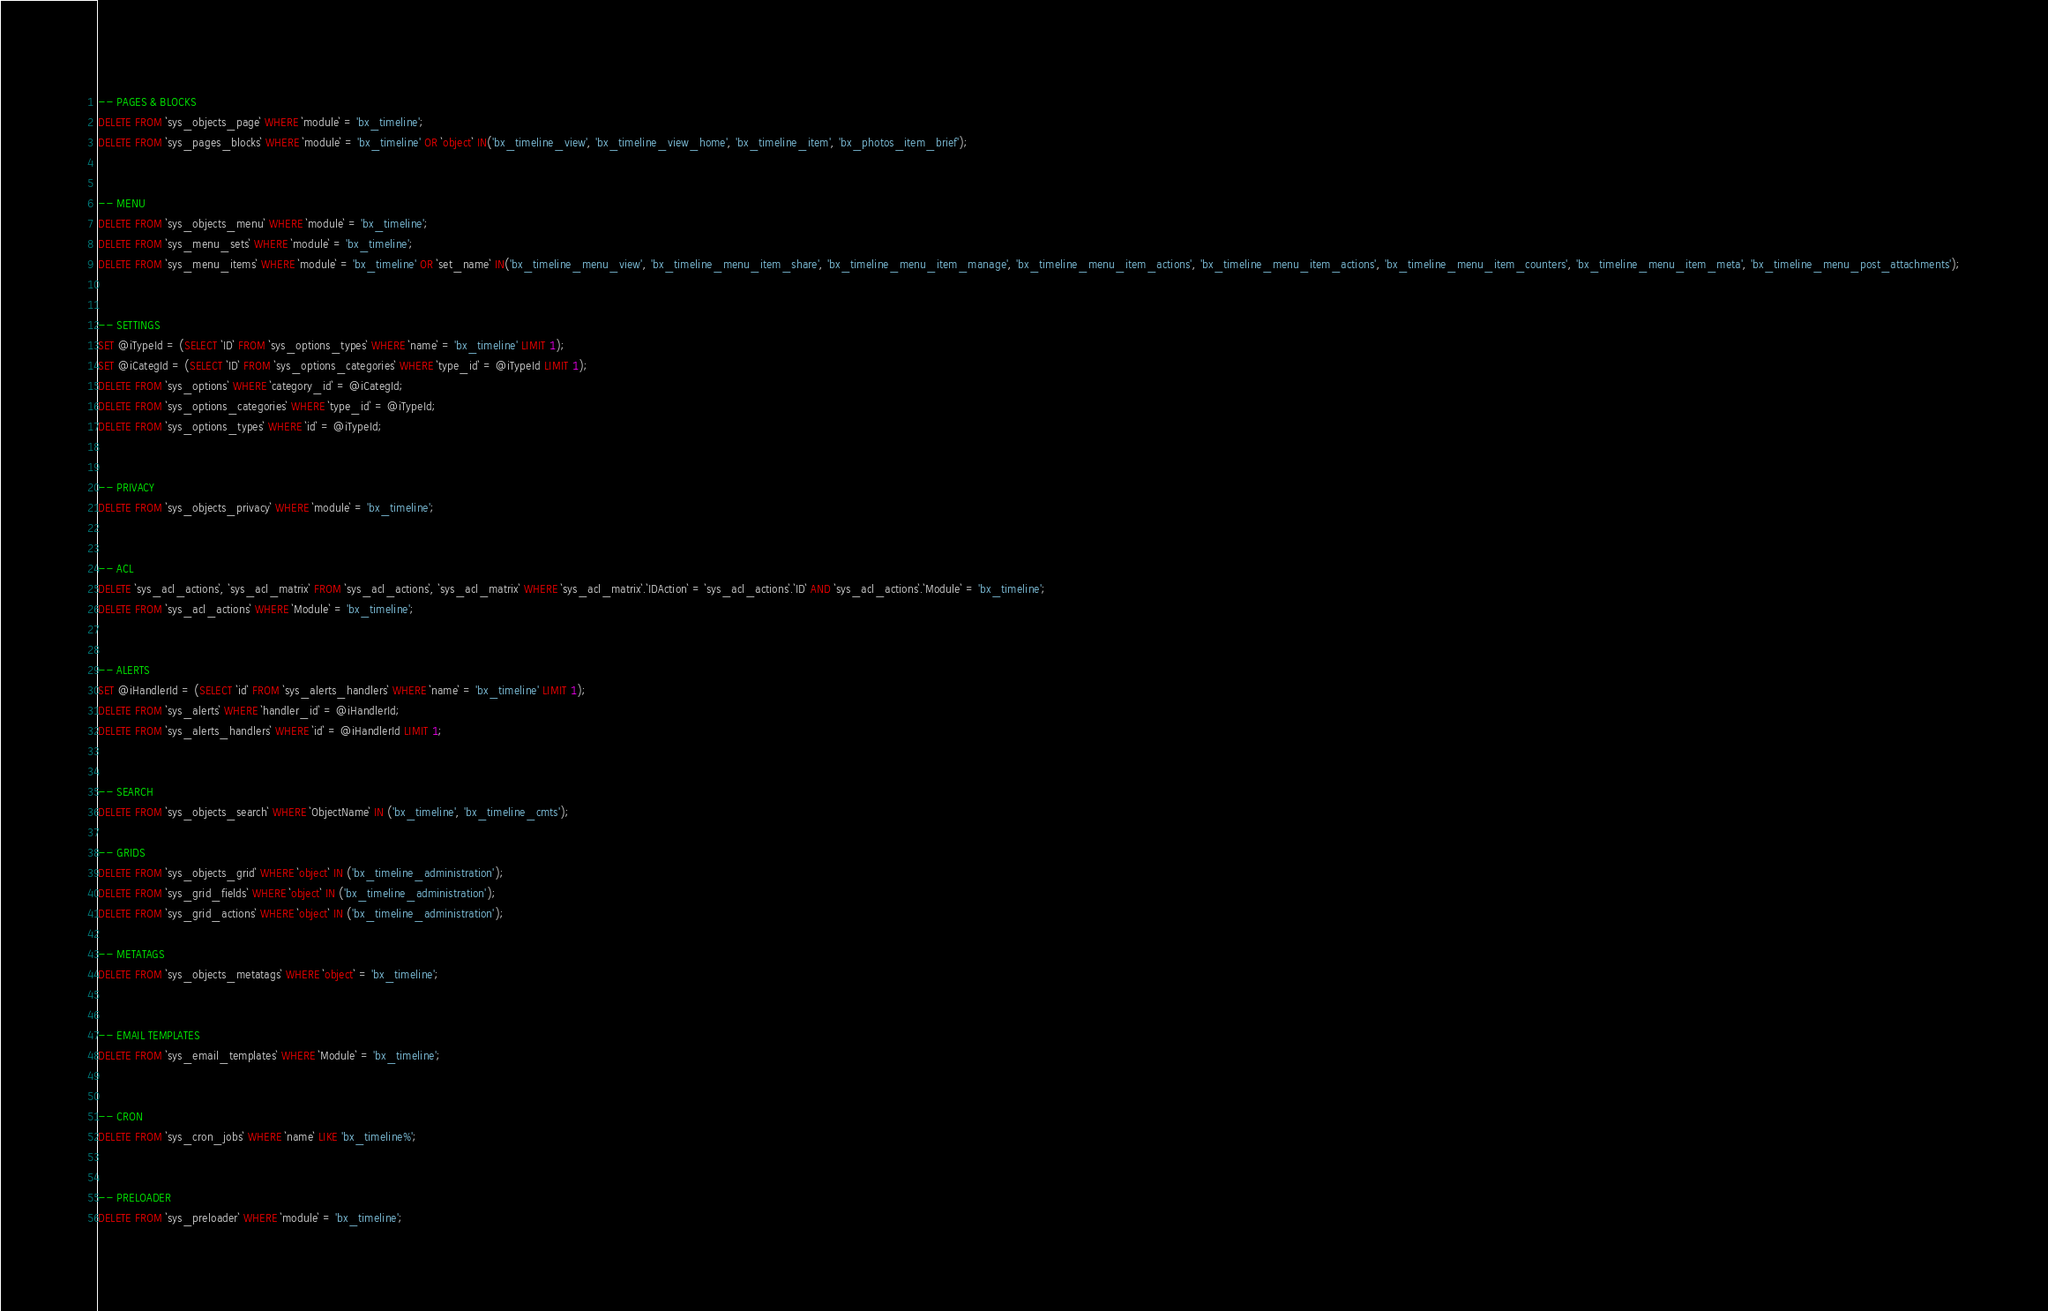Convert code to text. <code><loc_0><loc_0><loc_500><loc_500><_SQL_>-- PAGES & BLOCKS
DELETE FROM `sys_objects_page` WHERE `module` = 'bx_timeline';
DELETE FROM `sys_pages_blocks` WHERE `module` = 'bx_timeline' OR `object` IN('bx_timeline_view', 'bx_timeline_view_home', 'bx_timeline_item', 'bx_photos_item_brief');


-- MENU
DELETE FROM `sys_objects_menu` WHERE `module` = 'bx_timeline';
DELETE FROM `sys_menu_sets` WHERE `module` = 'bx_timeline';
DELETE FROM `sys_menu_items` WHERE `module` = 'bx_timeline' OR `set_name` IN('bx_timeline_menu_view', 'bx_timeline_menu_item_share', 'bx_timeline_menu_item_manage', 'bx_timeline_menu_item_actions', 'bx_timeline_menu_item_actions', 'bx_timeline_menu_item_counters', 'bx_timeline_menu_item_meta', 'bx_timeline_menu_post_attachments');


-- SETTINGS
SET @iTypeId = (SELECT `ID` FROM `sys_options_types` WHERE `name` = 'bx_timeline' LIMIT 1);
SET @iCategId = (SELECT `ID` FROM `sys_options_categories` WHERE `type_id` = @iTypeId LIMIT 1);
DELETE FROM `sys_options` WHERE `category_id` = @iCategId;
DELETE FROM `sys_options_categories` WHERE `type_id` = @iTypeId;
DELETE FROM `sys_options_types` WHERE `id` = @iTypeId;


-- PRIVACY 
DELETE FROM `sys_objects_privacy` WHERE `module` = 'bx_timeline';


-- ACL
DELETE `sys_acl_actions`, `sys_acl_matrix` FROM `sys_acl_actions`, `sys_acl_matrix` WHERE `sys_acl_matrix`.`IDAction` = `sys_acl_actions`.`ID` AND `sys_acl_actions`.`Module` = 'bx_timeline';
DELETE FROM `sys_acl_actions` WHERE `Module` = 'bx_timeline';


-- ALERTS
SET @iHandlerId = (SELECT `id` FROM `sys_alerts_handlers` WHERE `name` = 'bx_timeline' LIMIT 1);
DELETE FROM `sys_alerts` WHERE `handler_id` = @iHandlerId;
DELETE FROM `sys_alerts_handlers` WHERE `id` = @iHandlerId LIMIT 1;


-- SEARCH
DELETE FROM `sys_objects_search` WHERE `ObjectName` IN ('bx_timeline', 'bx_timeline_cmts');

-- GRIDS
DELETE FROM `sys_objects_grid` WHERE `object` IN ('bx_timeline_administration');
DELETE FROM `sys_grid_fields` WHERE `object` IN ('bx_timeline_administration');
DELETE FROM `sys_grid_actions` WHERE `object` IN ('bx_timeline_administration');

-- METATAGS
DELETE FROM `sys_objects_metatags` WHERE `object` = 'bx_timeline';


-- EMAIL TEMPLATES
DELETE FROM `sys_email_templates` WHERE `Module` = 'bx_timeline';


-- CRON
DELETE FROM `sys_cron_jobs` WHERE `name` LIKE 'bx_timeline%';


-- PRELOADER
DELETE FROM `sys_preloader` WHERE `module` = 'bx_timeline';
</code> 